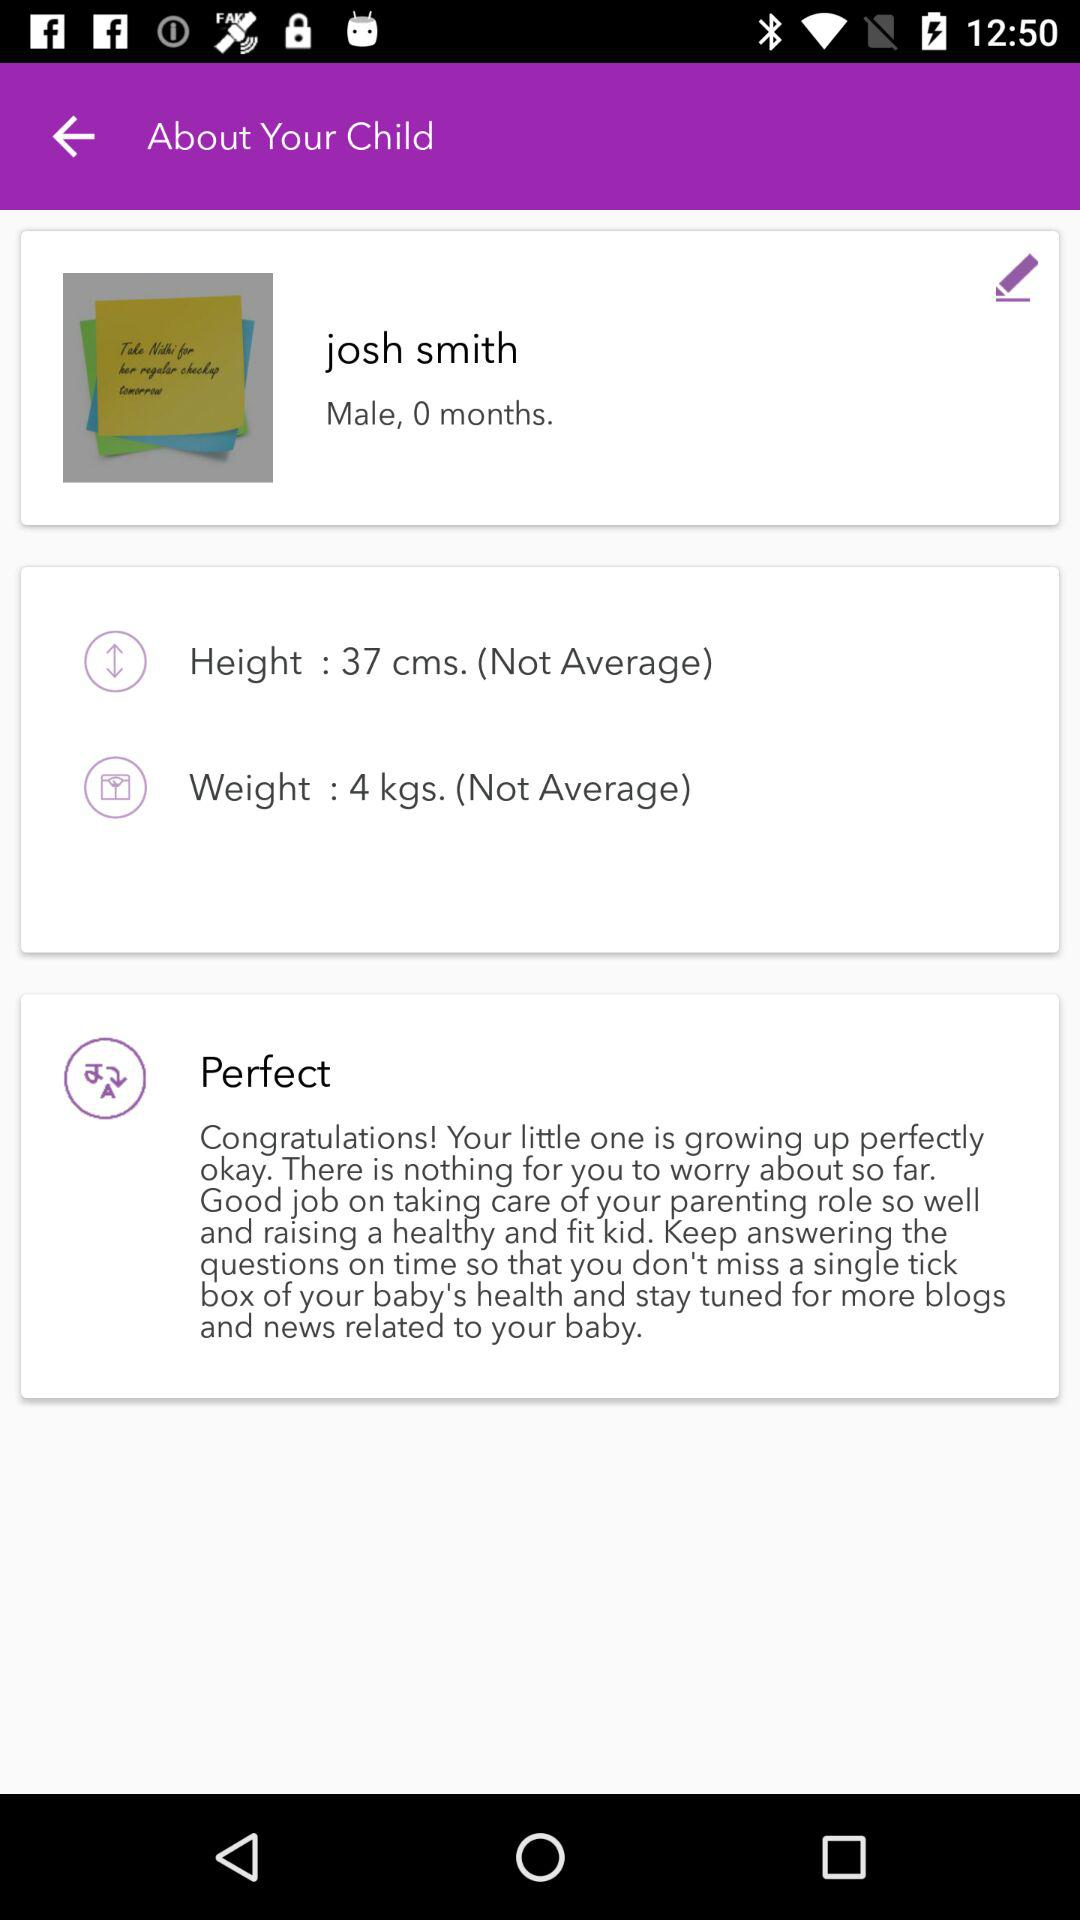What's the name? The name is Josh Smith. 